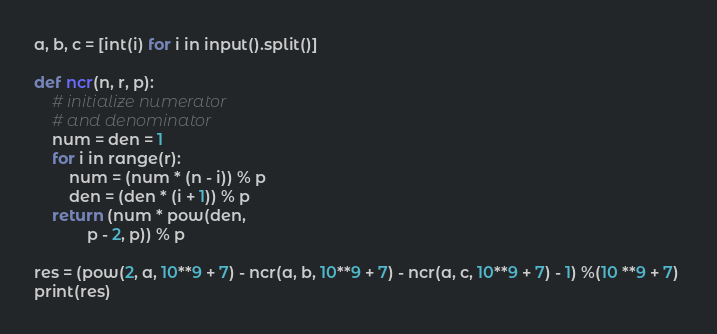<code> <loc_0><loc_0><loc_500><loc_500><_Python_>a, b, c = [int(i) for i in input().split()]

def ncr(n, r, p): 
    # initialize numerator 
    # and denominator 
    num = den = 1 
    for i in range(r): 
        num = (num * (n - i)) % p 
        den = (den * (i + 1)) % p 
    return (num * pow(den,  
            p - 2, p)) % p 

res = (pow(2, a, 10**9 + 7) - ncr(a, b, 10**9 + 7) - ncr(a, c, 10**9 + 7) - 1) %(10 **9 + 7) 
print(res)</code> 